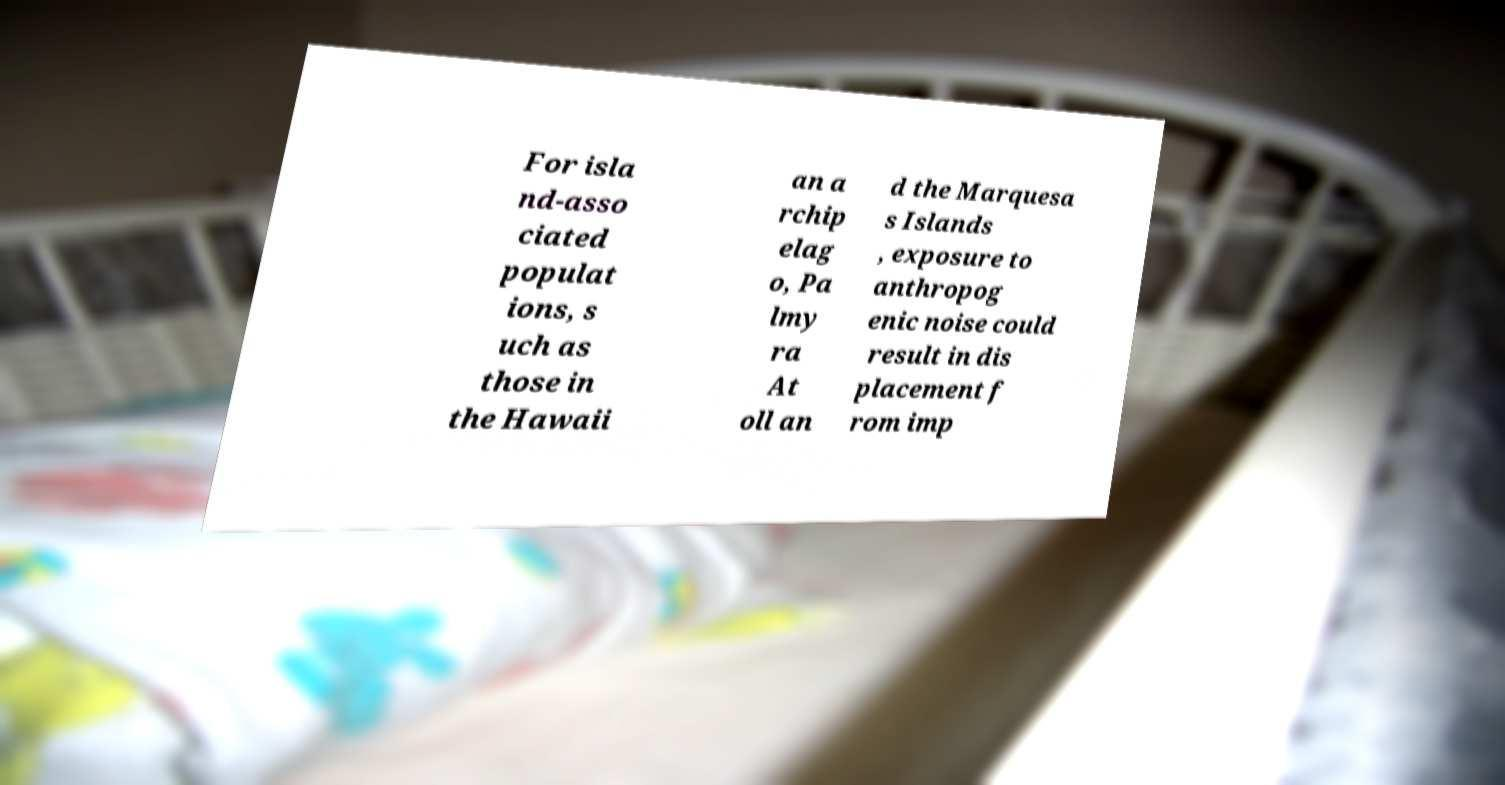Can you accurately transcribe the text from the provided image for me? For isla nd-asso ciated populat ions, s uch as those in the Hawaii an a rchip elag o, Pa lmy ra At oll an d the Marquesa s Islands , exposure to anthropog enic noise could result in dis placement f rom imp 